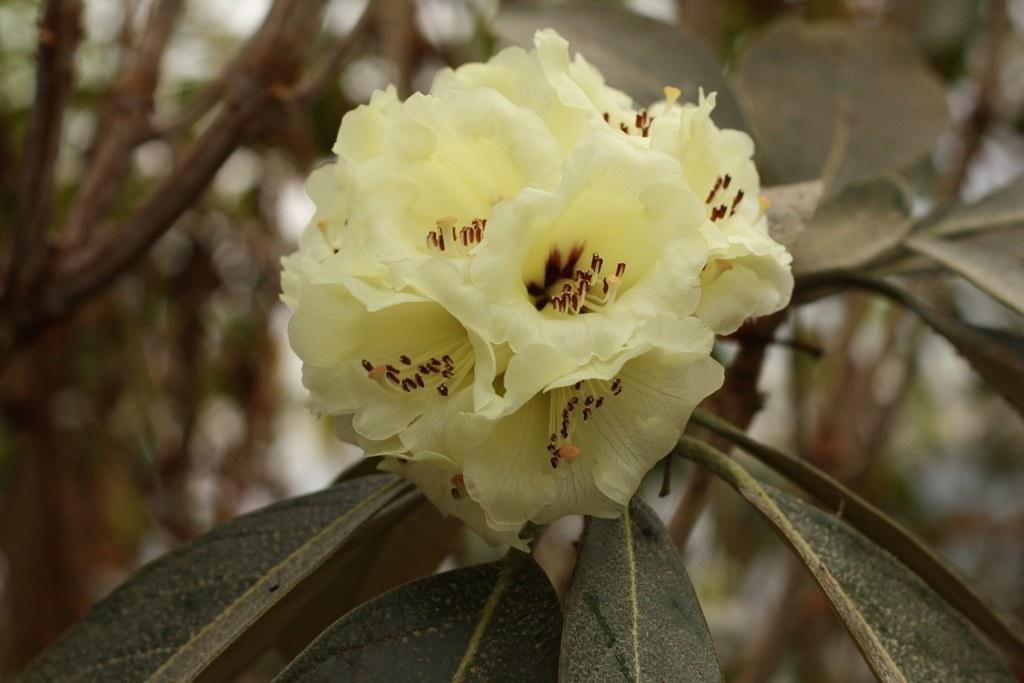Could you give a brief overview of what you see in this image? These are the flowers in yellow color and these are the green leaves. 